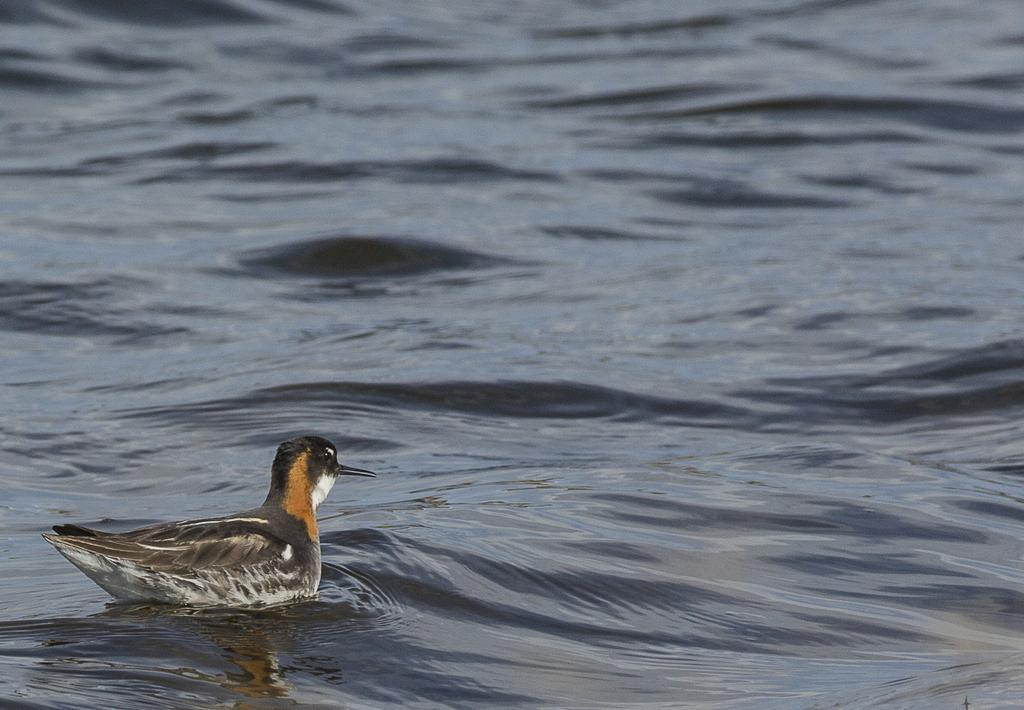What animal is present in the image? There is a duck in the image. Where is the duck located? The duck is in the water. What type of riddle does the woman solve using the net in the image? There is no woman or net present in the image, and therefore no such activity can be observed. 